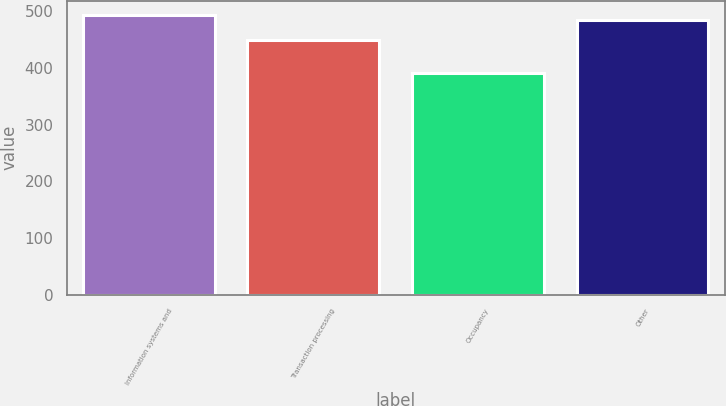Convert chart to OTSL. <chart><loc_0><loc_0><loc_500><loc_500><bar_chart><fcel>Information systems and<fcel>Transaction processing<fcel>Occupancy<fcel>Other<nl><fcel>493.5<fcel>449<fcel>391<fcel>484<nl></chart> 